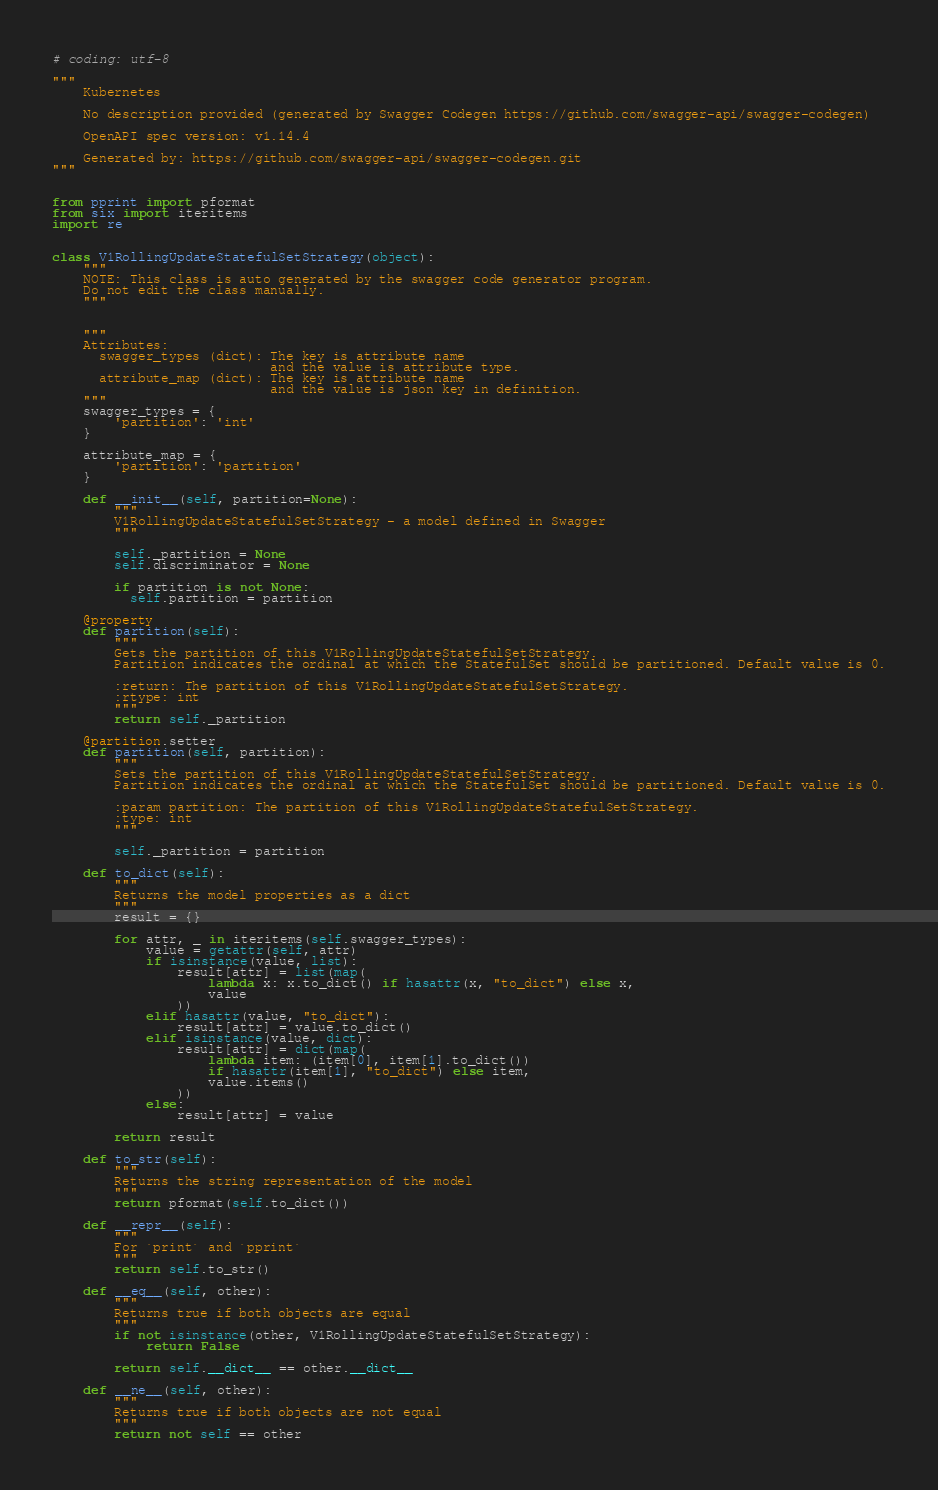<code> <loc_0><loc_0><loc_500><loc_500><_Python_># coding: utf-8

"""
    Kubernetes

    No description provided (generated by Swagger Codegen https://github.com/swagger-api/swagger-codegen)

    OpenAPI spec version: v1.14.4
    
    Generated by: https://github.com/swagger-api/swagger-codegen.git
"""


from pprint import pformat
from six import iteritems
import re


class V1RollingUpdateStatefulSetStrategy(object):
    """
    NOTE: This class is auto generated by the swagger code generator program.
    Do not edit the class manually.
    """


    """
    Attributes:
      swagger_types (dict): The key is attribute name
                            and the value is attribute type.
      attribute_map (dict): The key is attribute name
                            and the value is json key in definition.
    """
    swagger_types = {
        'partition': 'int'
    }

    attribute_map = {
        'partition': 'partition'
    }

    def __init__(self, partition=None):
        """
        V1RollingUpdateStatefulSetStrategy - a model defined in Swagger
        """

        self._partition = None
        self.discriminator = None

        if partition is not None:
          self.partition = partition

    @property
    def partition(self):
        """
        Gets the partition of this V1RollingUpdateStatefulSetStrategy.
        Partition indicates the ordinal at which the StatefulSet should be partitioned. Default value is 0.

        :return: The partition of this V1RollingUpdateStatefulSetStrategy.
        :rtype: int
        """
        return self._partition

    @partition.setter
    def partition(self, partition):
        """
        Sets the partition of this V1RollingUpdateStatefulSetStrategy.
        Partition indicates the ordinal at which the StatefulSet should be partitioned. Default value is 0.

        :param partition: The partition of this V1RollingUpdateStatefulSetStrategy.
        :type: int
        """

        self._partition = partition

    def to_dict(self):
        """
        Returns the model properties as a dict
        """
        result = {}

        for attr, _ in iteritems(self.swagger_types):
            value = getattr(self, attr)
            if isinstance(value, list):
                result[attr] = list(map(
                    lambda x: x.to_dict() if hasattr(x, "to_dict") else x,
                    value
                ))
            elif hasattr(value, "to_dict"):
                result[attr] = value.to_dict()
            elif isinstance(value, dict):
                result[attr] = dict(map(
                    lambda item: (item[0], item[1].to_dict())
                    if hasattr(item[1], "to_dict") else item,
                    value.items()
                ))
            else:
                result[attr] = value

        return result

    def to_str(self):
        """
        Returns the string representation of the model
        """
        return pformat(self.to_dict())

    def __repr__(self):
        """
        For `print` and `pprint`
        """
        return self.to_str()

    def __eq__(self, other):
        """
        Returns true if both objects are equal
        """
        if not isinstance(other, V1RollingUpdateStatefulSetStrategy):
            return False

        return self.__dict__ == other.__dict__

    def __ne__(self, other):
        """
        Returns true if both objects are not equal
        """
        return not self == other
</code> 